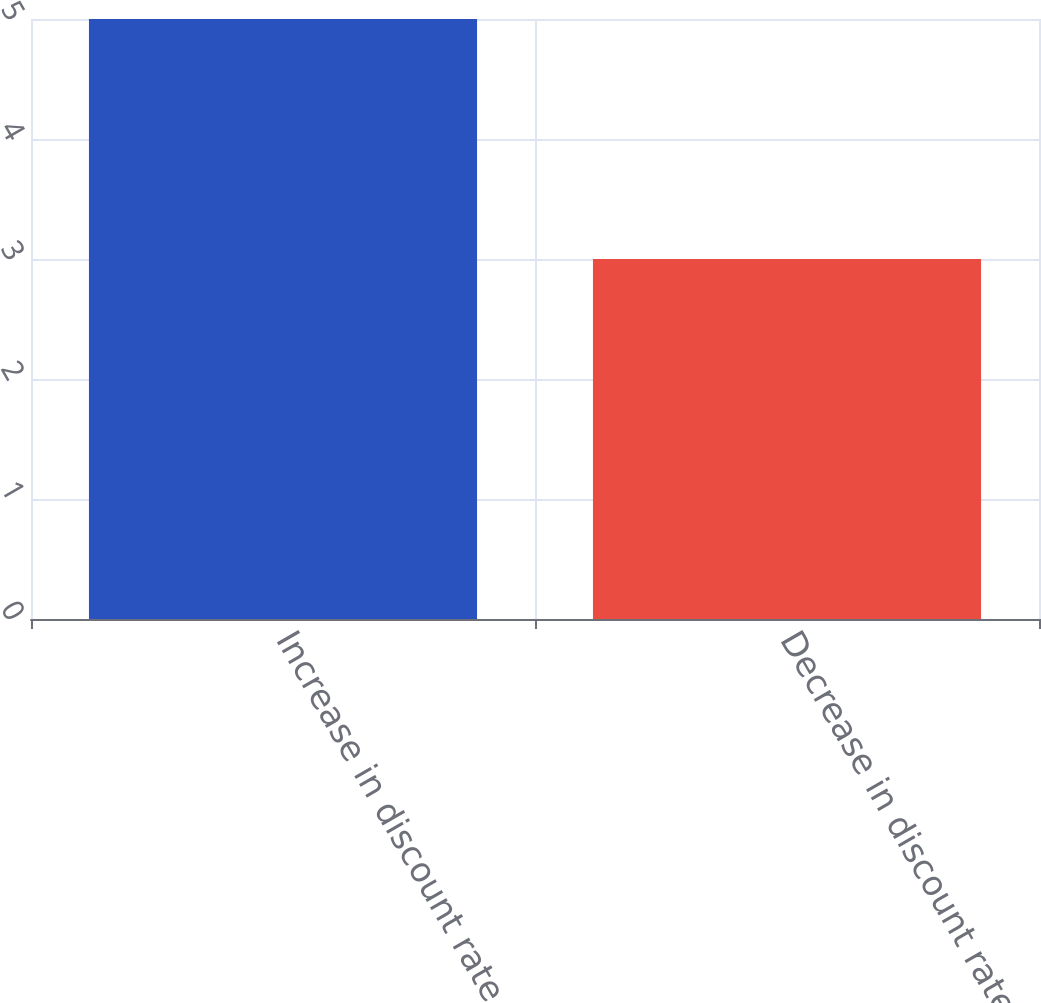Convert chart. <chart><loc_0><loc_0><loc_500><loc_500><bar_chart><fcel>Increase in discount rate by<fcel>Decrease in discount rate by<nl><fcel>5<fcel>3<nl></chart> 